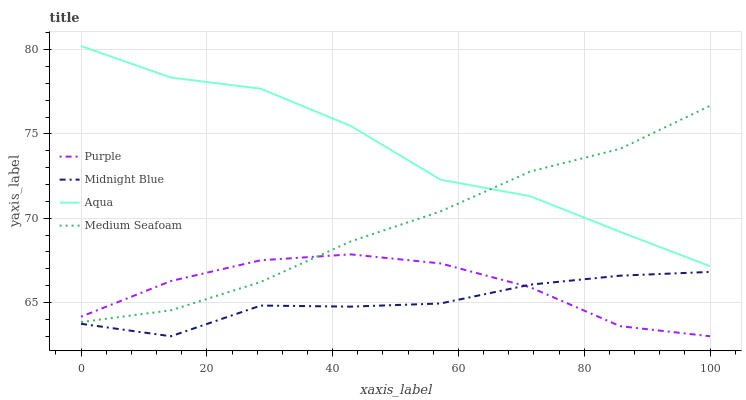Does Aqua have the minimum area under the curve?
Answer yes or no. No. Does Midnight Blue have the maximum area under the curve?
Answer yes or no. No. Is Midnight Blue the smoothest?
Answer yes or no. No. Is Midnight Blue the roughest?
Answer yes or no. No. Does Aqua have the lowest value?
Answer yes or no. No. Does Midnight Blue have the highest value?
Answer yes or no. No. Is Midnight Blue less than Medium Seafoam?
Answer yes or no. Yes. Is Aqua greater than Midnight Blue?
Answer yes or no. Yes. Does Midnight Blue intersect Medium Seafoam?
Answer yes or no. No. 